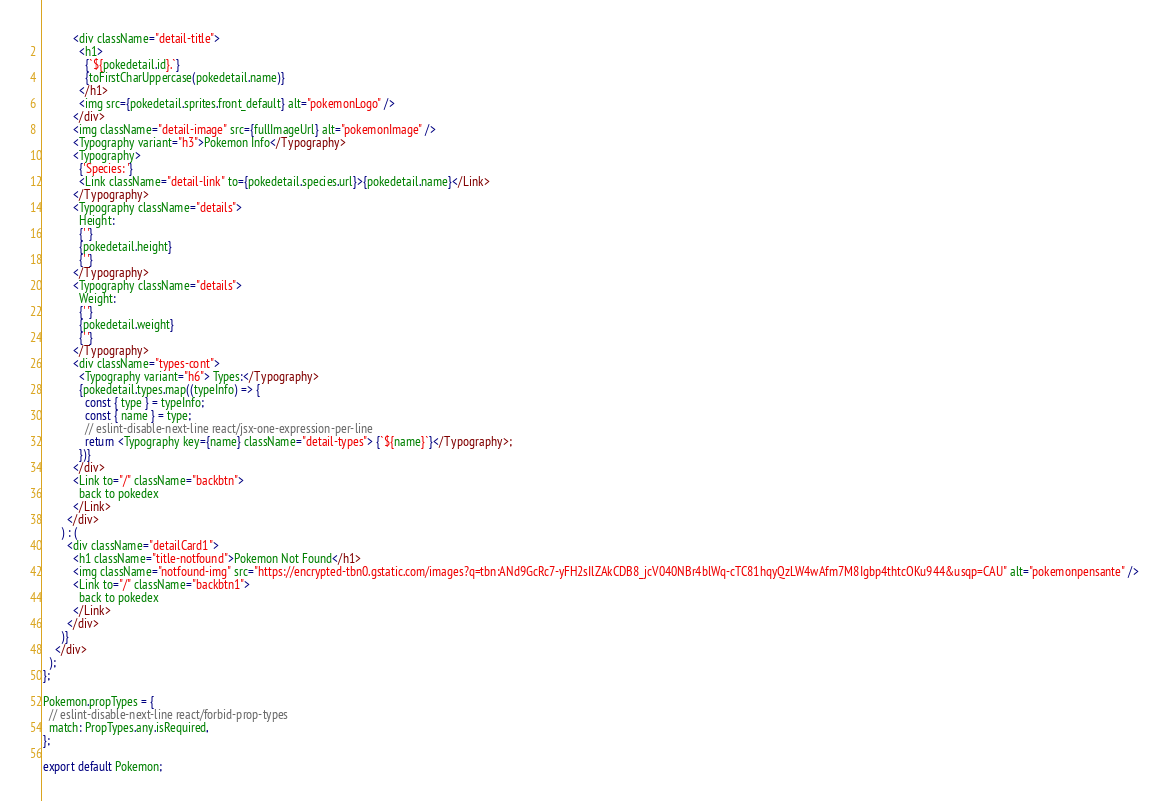<code> <loc_0><loc_0><loc_500><loc_500><_JavaScript_>          <div className="detail-title">
            <h1>
              {`${pokedetail.id}.`}
              {toFirstCharUppercase(pokedetail.name)}
            </h1>
            <img src={pokedetail.sprites.front_default} alt="pokemonLogo" />
          </div>
          <img className="detail-image" src={fullImageUrl} alt="pokemonImage" />
          <Typography variant="h3">Pokemon Info</Typography>
          <Typography>
            {'Species: '}
            <Link className="detail-link" to={pokedetail.species.url}>{pokedetail.name}</Link>
          </Typography>
          <Typography className="details">
            Height:
            {' '}
            {pokedetail.height}
            {' '}
          </Typography>
          <Typography className="details">
            Weight:
            {' '}
            {pokedetail.weight}
            {' '}
          </Typography>
          <div className="types-cont">
            <Typography variant="h6"> Types:</Typography>
            {pokedetail.types.map((typeInfo) => {
              const { type } = typeInfo;
              const { name } = type;
              // eslint-disable-next-line react/jsx-one-expression-per-line
              return <Typography key={name} className="detail-types"> {`${name}`}</Typography>;
            })}
          </div>
          <Link to="/" className="backbtn">
            back to pokedex
          </Link>
        </div>
      ) : (
        <div className="detailCard1">
          <h1 className="title-notfound">Pokemon Not Found</h1>
          <img className="notfound-img" src="https://encrypted-tbn0.gstatic.com/images?q=tbn:ANd9GcRc7-yFH2sIlZAkCDB8_jcV040NBr4blWq-cTC81hqyQzLW4wAfm7M8Igbp4thtcOKu944&usqp=CAU" alt="pokemonpensante" />
          <Link to="/" className="backbtn1">
            back to pokedex
          </Link>
        </div>
      )}
    </div>
  );
};

Pokemon.propTypes = {
  // eslint-disable-next-line react/forbid-prop-types
  match: PropTypes.any.isRequired,
};

export default Pokemon;
</code> 